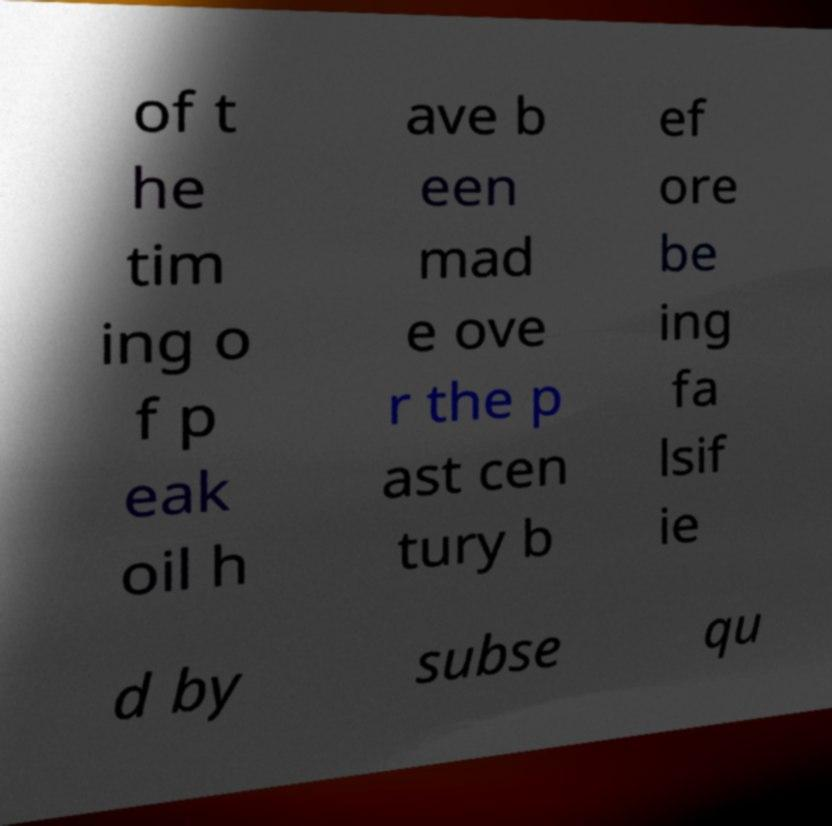What messages or text are displayed in this image? I need them in a readable, typed format. of t he tim ing o f p eak oil h ave b een mad e ove r the p ast cen tury b ef ore be ing fa lsif ie d by subse qu 